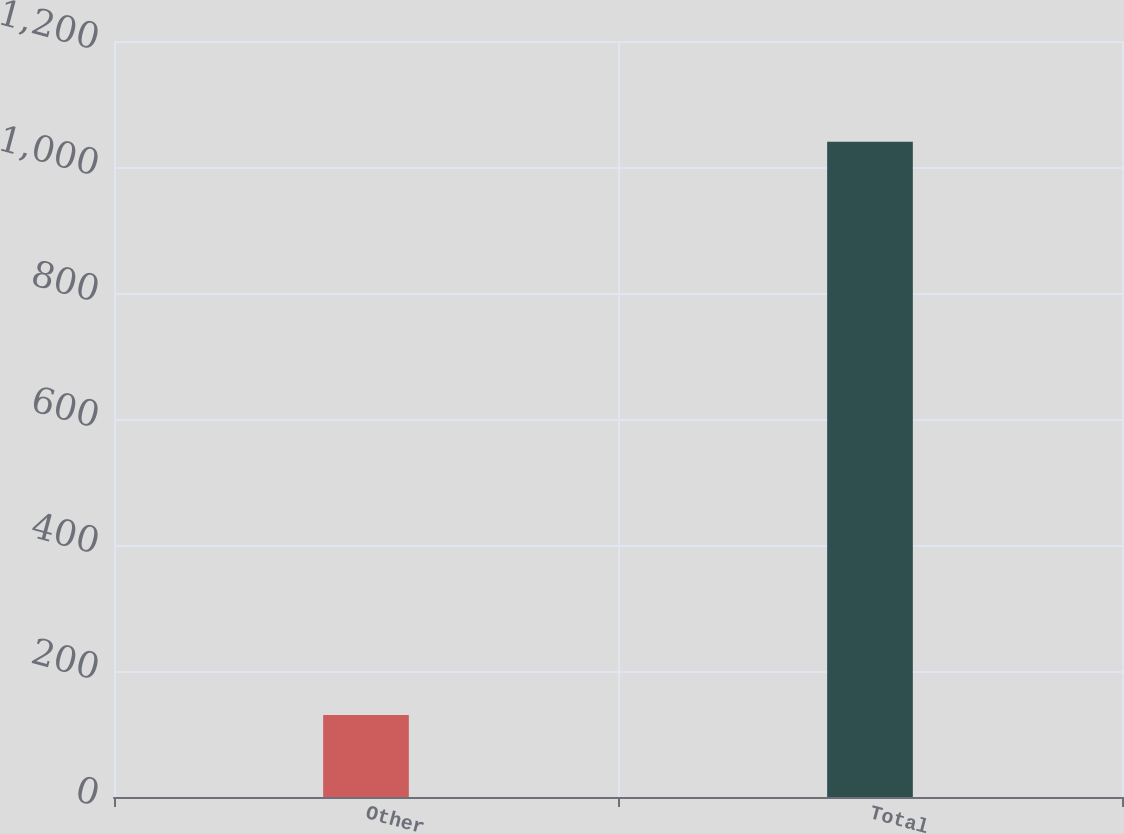<chart> <loc_0><loc_0><loc_500><loc_500><bar_chart><fcel>Other<fcel>Total<nl><fcel>130<fcel>1040<nl></chart> 